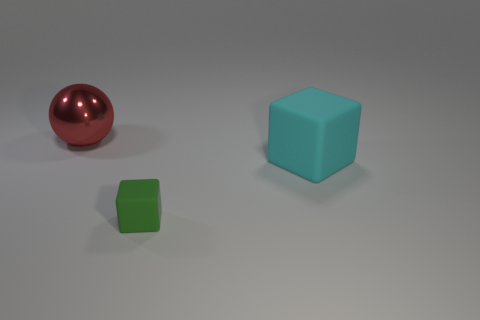Add 2 large matte cubes. How many objects exist? 5 Subtract all green blocks. How many blocks are left? 1 Subtract all cubes. How many objects are left? 1 Subtract 1 green blocks. How many objects are left? 2 Subtract all purple blocks. Subtract all gray balls. How many blocks are left? 2 Subtract all purple spheres. How many gray blocks are left? 0 Subtract all yellow shiny cubes. Subtract all big objects. How many objects are left? 1 Add 2 big red balls. How many big red balls are left? 3 Add 1 small blocks. How many small blocks exist? 2 